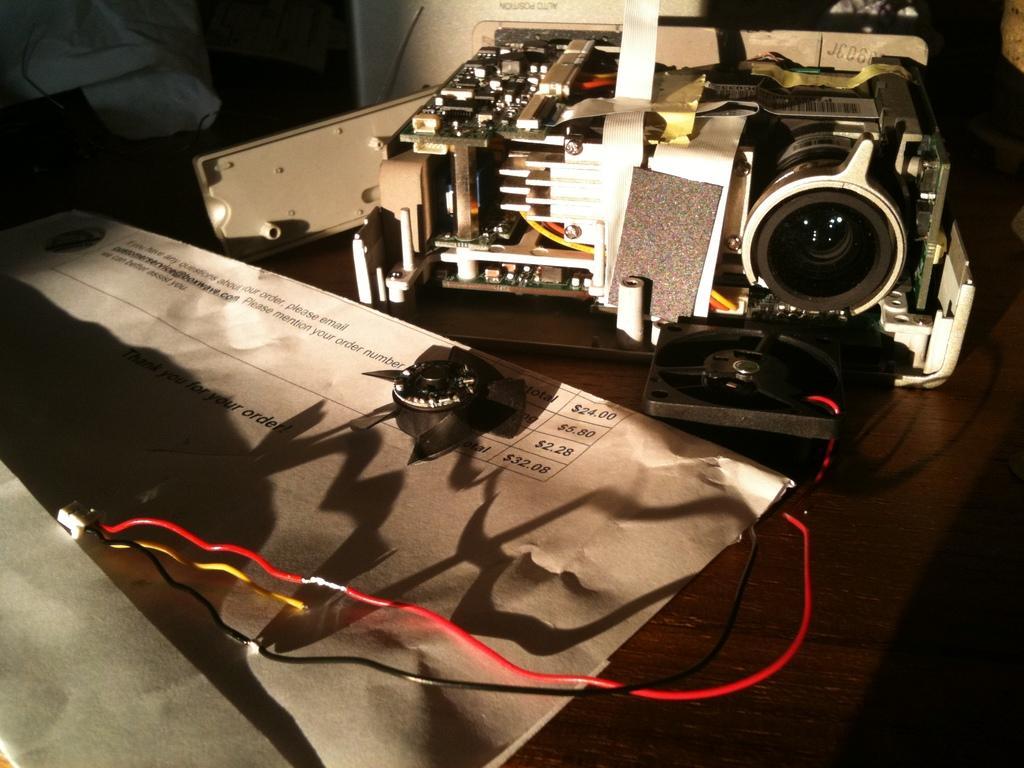Please provide a concise description of this image. In this picture there is a projector lens machine, placed on the wooden table. Beside there is a brown color envelope, red color cables and small black color computer fan. 